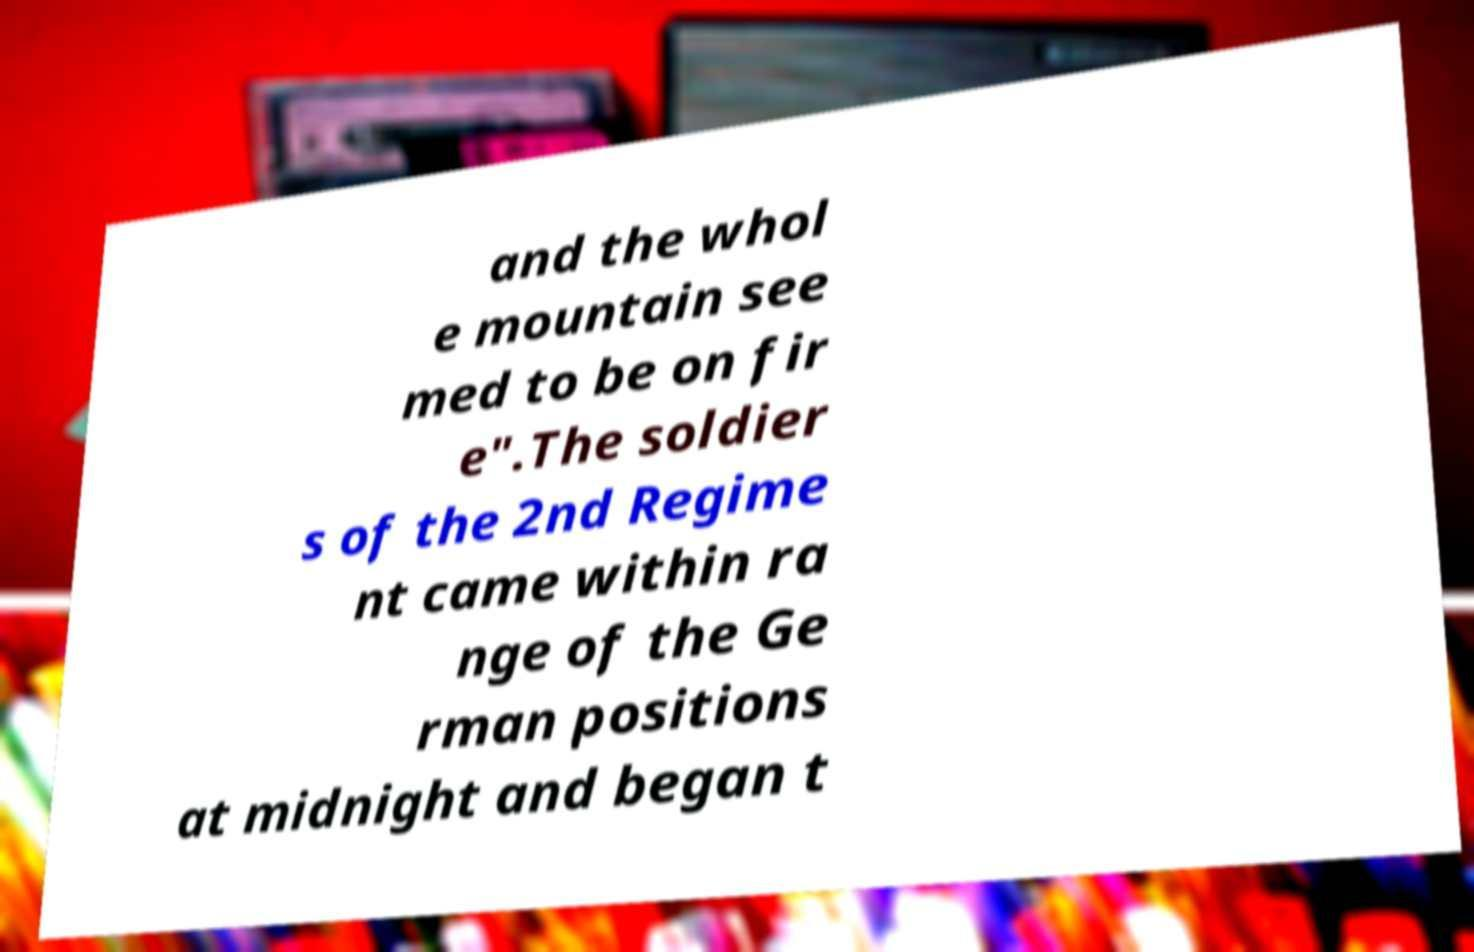Could you assist in decoding the text presented in this image and type it out clearly? and the whol e mountain see med to be on fir e".The soldier s of the 2nd Regime nt came within ra nge of the Ge rman positions at midnight and began t 